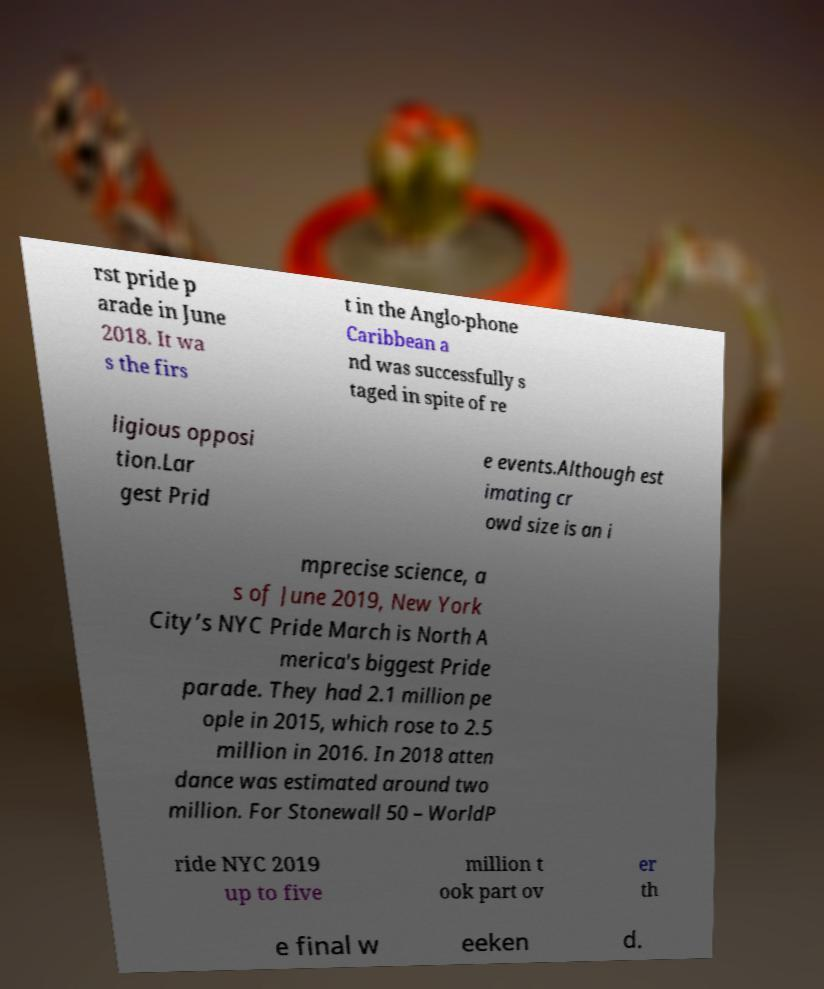For documentation purposes, I need the text within this image transcribed. Could you provide that? rst pride p arade in June 2018. It wa s the firs t in the Anglo-phone Caribbean a nd was successfully s taged in spite of re ligious opposi tion.Lar gest Prid e events.Although est imating cr owd size is an i mprecise science, a s of June 2019, New York City’s NYC Pride March is North A merica's biggest Pride parade. They had 2.1 million pe ople in 2015, which rose to 2.5 million in 2016. In 2018 atten dance was estimated around two million. For Stonewall 50 – WorldP ride NYC 2019 up to five million t ook part ov er th e final w eeken d. 